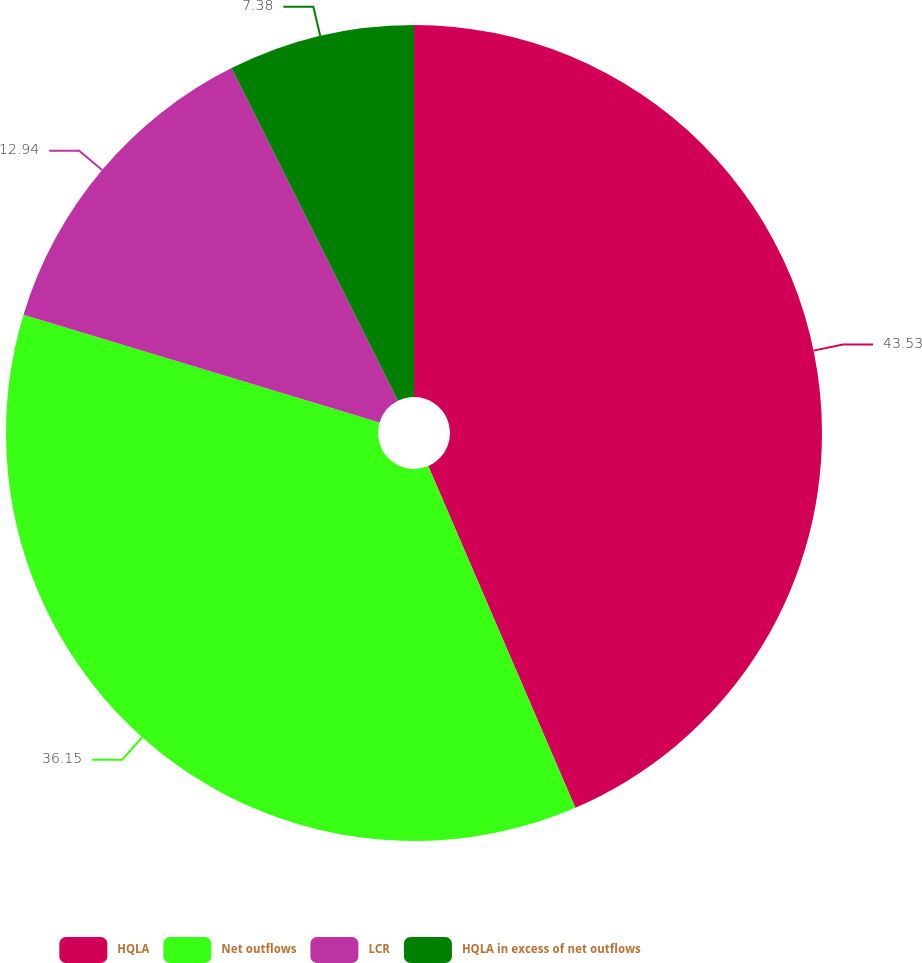Convert chart to OTSL. <chart><loc_0><loc_0><loc_500><loc_500><pie_chart><fcel>HQLA<fcel>Net outflows<fcel>LCR<fcel>HQLA in excess of net outflows<nl><fcel>43.53%<fcel>36.15%<fcel>12.94%<fcel>7.38%<nl></chart> 